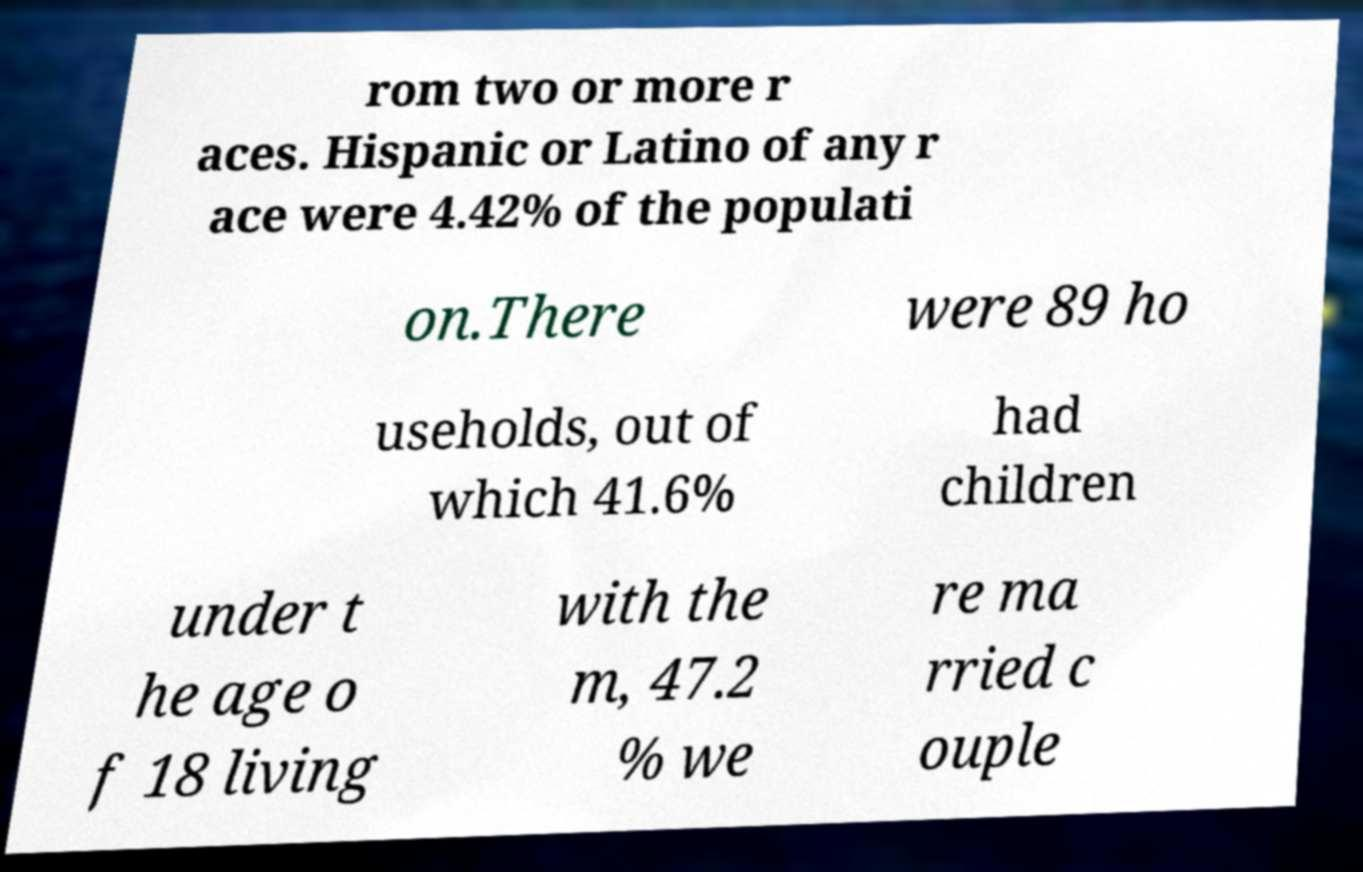Can you accurately transcribe the text from the provided image for me? rom two or more r aces. Hispanic or Latino of any r ace were 4.42% of the populati on.There were 89 ho useholds, out of which 41.6% had children under t he age o f 18 living with the m, 47.2 % we re ma rried c ouple 